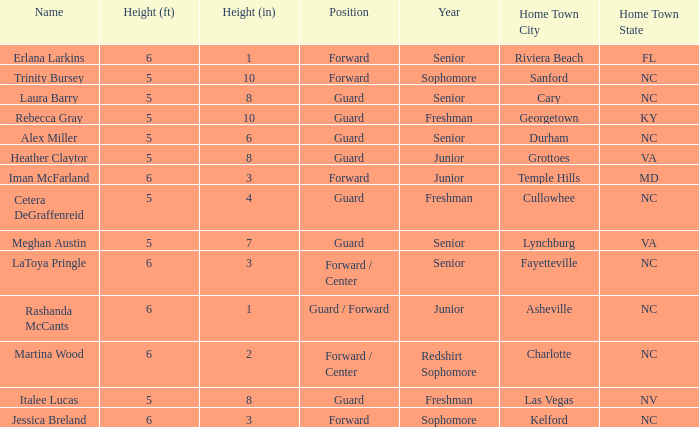What is the name of the guard from Cary, NC? Laura Barry. 